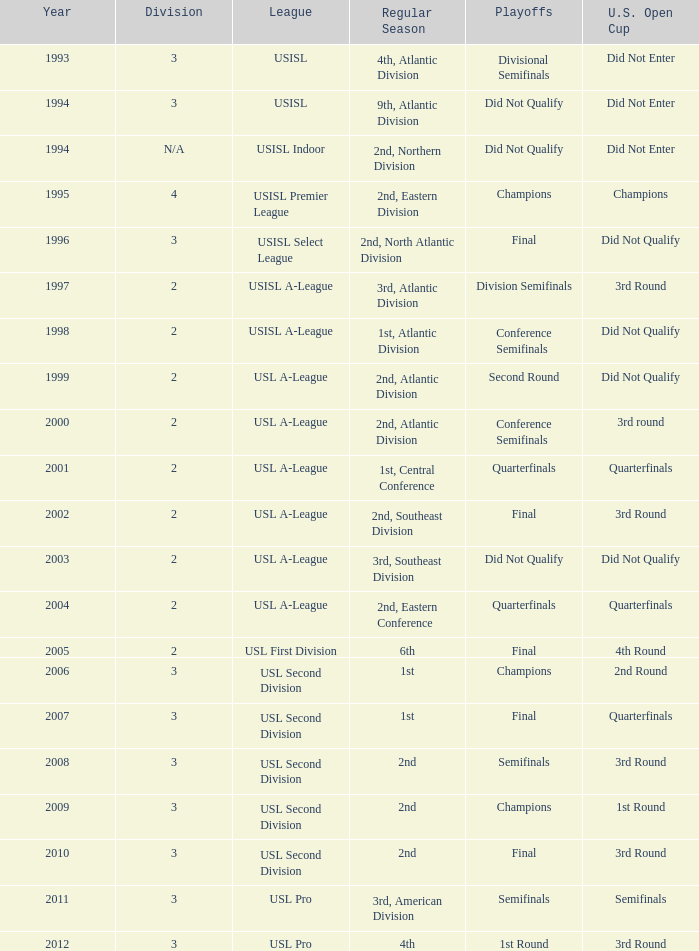What's the u.s. open cup position for the normal season of 4th, atlantic division? Did Not Enter. 